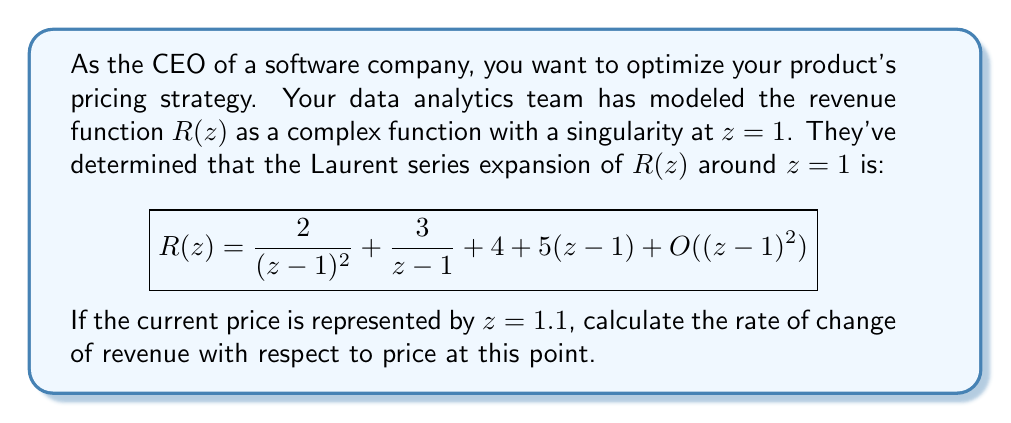Could you help me with this problem? To solve this problem, we need to follow these steps:

1) The rate of change of revenue with respect to price is given by the derivative of $R(z)$ at $z=1.1$.

2) To find the derivative, we need to differentiate the Laurent series term by term:

   $$R'(z) = -\frac{4}{(z-1)^3} - \frac{3}{(z-1)^2} + 5 + O(z-1)$$

3) Now we need to evaluate this at $z=1.1$. Let's substitute $z=1.1$ into each term:

   a) $-\frac{4}{(1.1-1)^3} = -\frac{4}{0.1^3} = -4000$

   b) $-\frac{3}{(1.1-1)^2} = -\frac{3}{0.1^2} = -300$

   c) $5$ remains as $5$

4) Adding these terms:

   $R'(1.1) = -4000 - 300 + 5 = -4295$

5) The $O(z-1)$ term becomes negligible as $z$ approaches 1, so we can ignore it for this calculation.

Therefore, the rate of change of revenue with respect to price at $z=1.1$ is -4295.
Answer: $-4295$ 